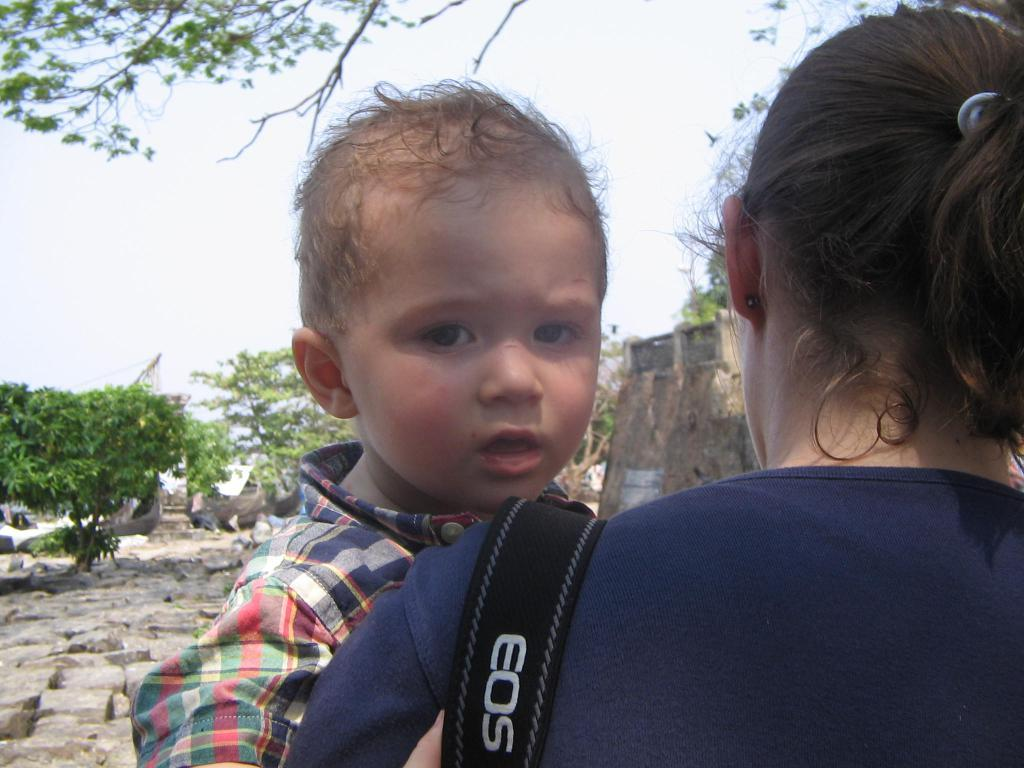Who is the main subject in the image? There is a woman in the image. What is the woman wearing? The woman is wearing a blue t-shirt. What is the woman doing in the image? The woman is holding a small baby on her shoulder. What is the baby doing in the image? The baby is looking into the camera. What can be seen in the background of the image? There are trees and a brown color wall visible in the background of the image. What type of engine can be seen in the image? There is no engine present in the image. What color is the visitor's shirt in the image? There is no visitor present in the image, so we cannot determine the color of their shirt. 